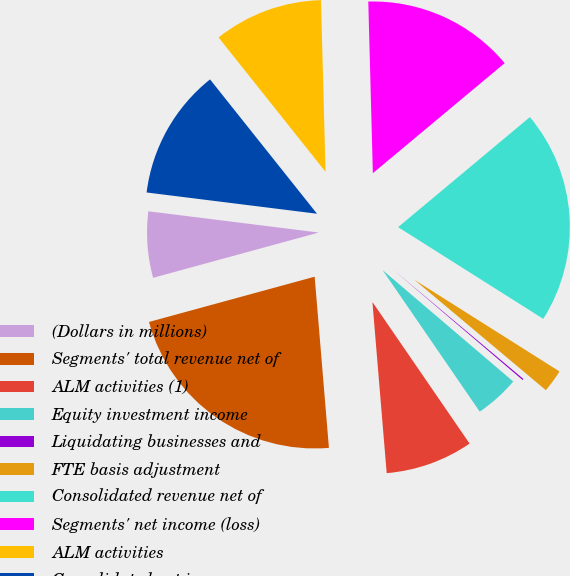Convert chart to OTSL. <chart><loc_0><loc_0><loc_500><loc_500><pie_chart><fcel>(Dollars in millions)<fcel>Segments' total revenue net of<fcel>ALM activities (1)<fcel>Equity investment income<fcel>Liquidating businesses and<fcel>FTE basis adjustment<fcel>Consolidated revenue net of<fcel>Segments' net income (loss)<fcel>ALM activities<fcel>Consolidated net income<nl><fcel>6.22%<fcel>22.08%<fcel>8.25%<fcel>4.19%<fcel>0.12%<fcel>2.15%<fcel>20.04%<fcel>14.35%<fcel>10.28%<fcel>12.32%<nl></chart> 